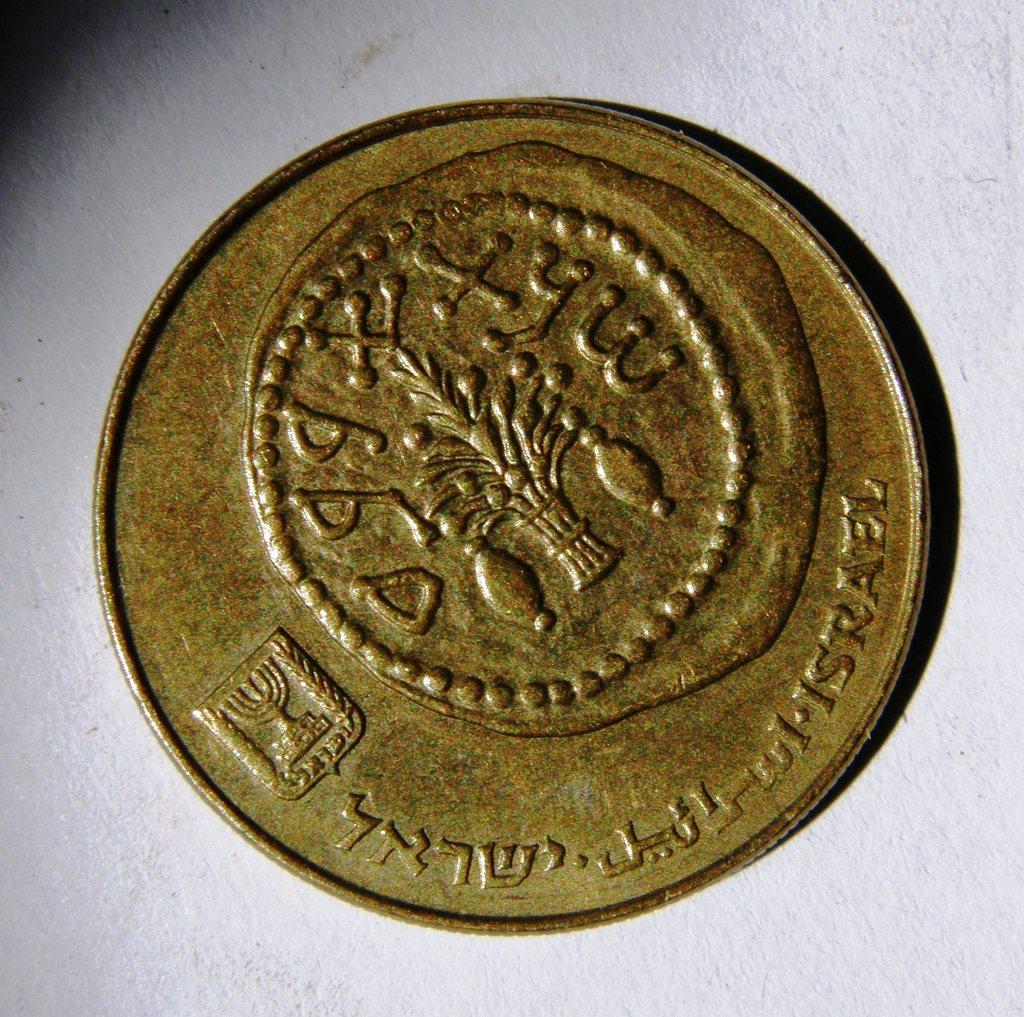<image>
Create a compact narrative representing the image presented. An old looking coin with the word Israel visible at the bottom left. 